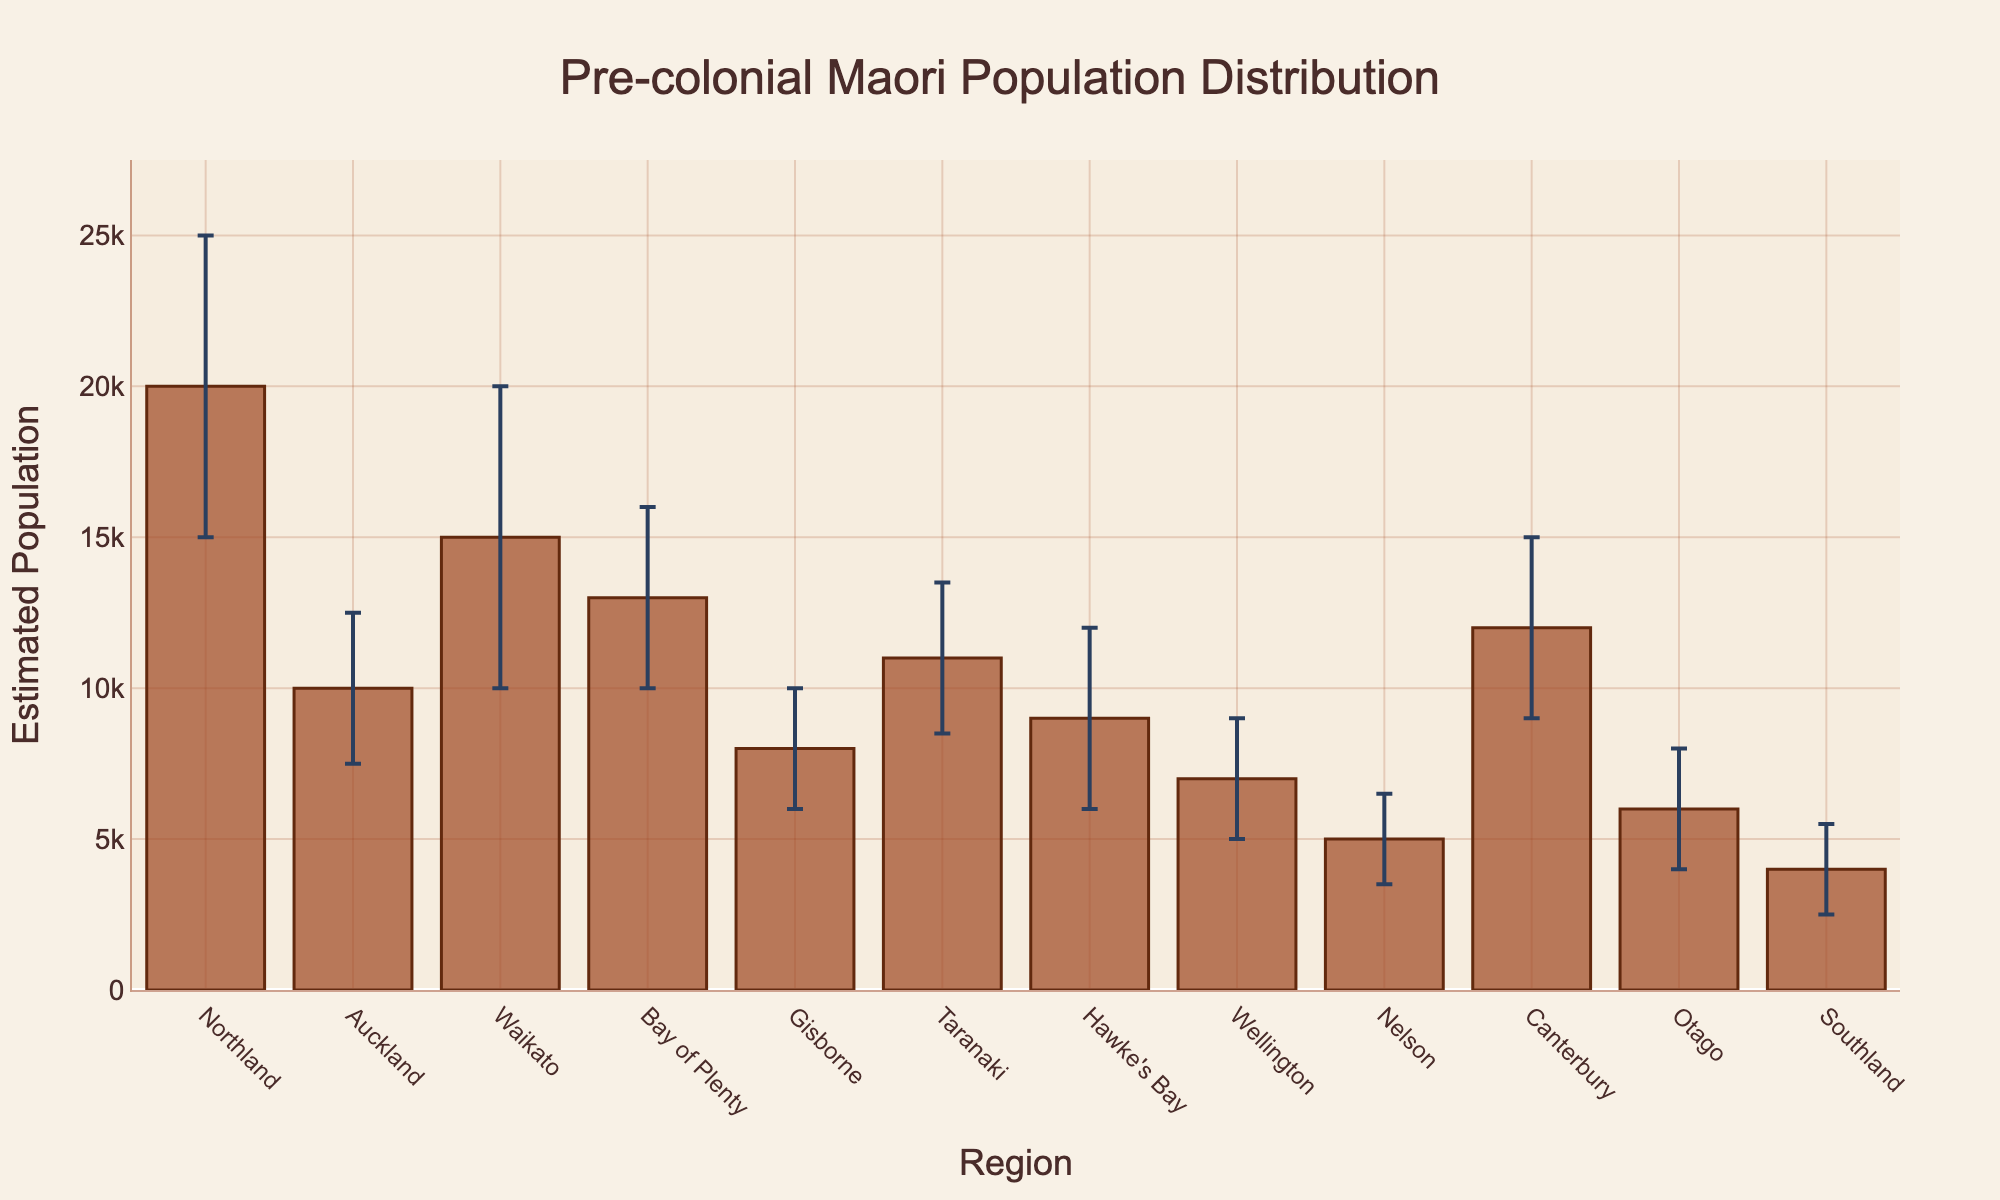What is the title of the figure? The title is located at the top of the figure. It is clearly stated and easy to read.
Answer: Pre-colonial Maori Population Distribution Which region has the highest population estimate? By looking at the heights of the bars, the region with the highest bar represents the highest population estimate.
Answer: Northland What is the population estimate for Canterbury? Find the bar corresponding to Canterbury and read the value on the y-axis.
Answer: 12,000 Which region has the largest uncertainty in its population estimate? Compare the lengths of the error bars (distance between upper and lower bounds) for each region.
Answer: Waikato What is the approximate range of the population estimate for Waikato? The upper and lower bounds can be read directly from the error bars on the Waikato bar.
Answer: 10,000 to 20,000 How many regions have an estimated population of 10,000 or more? Identify all bars with their y-value at or above 10,000. Count these bars.
Answer: 6 Which region has the lowest estimated population? Find the bar with the shortest height, indicating the lowest population estimate.
Answer: Southland What is the difference between the upper bound and lower bound for Taranaki? Subtract the lower bound from the upper bound for Taranaki. The values are 13,500 and 8,500 respectively. 13,500 - 8,500 = 5,000.
Answer: 5,000 Which regions have error bars that overlap with Northland's population estimate? Determine the population range for Northland and then check which regions have error bars within or intersecting this range (15,000 - 25,000).
Answer: Auckland, Waikato, Bay of Plenty, Canterbury What is the average population estimate for Wellington, Nelson, and Otago? Add the population estimates for Wellington (7,000), Nelson (5,000), and Otago (6,000), then divide by 3. (7,000 + 5,000 + 6,000) / 3 = 6,000
Answer: 6,000 